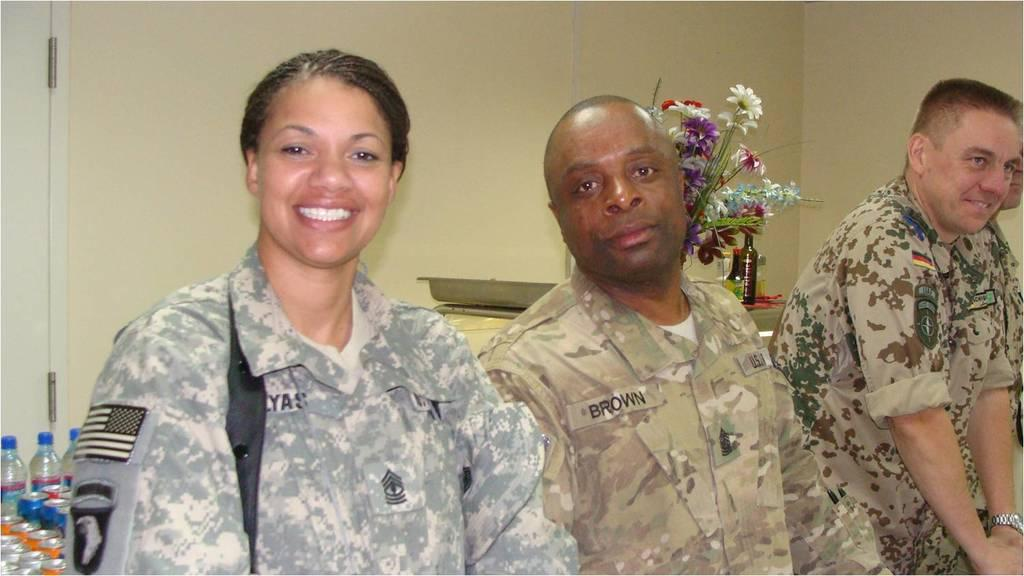How many people are present in the image? There are three people in the image: two men and a woman. What are the people wearing in the image? The people are wearing army clothes in the image. What objects can be seen in the image besides the people? There are bottles and a flower plant visible in the image. Can you tell me how many giraffes are present in the image? There are no giraffes present in the image; it features two men and a woman wearing army clothes, along with bottles and a flower plant. How many people are walking in the image? The provided facts do not mention anyone walking in the image, so it cannot be determined from the information given. 